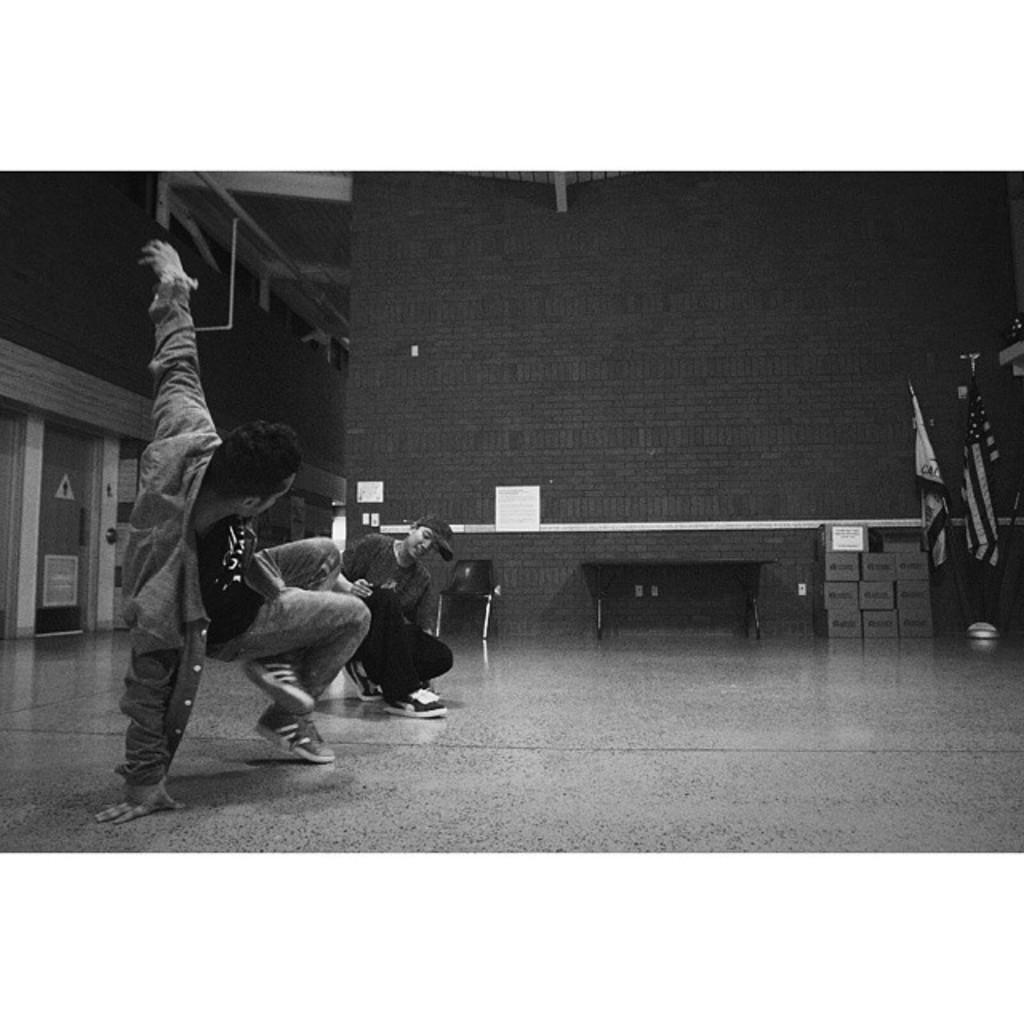What are the two men in the image doing? The two men are dancing in the image. Where are the men dancing? The men are dancing on the floor. What can be seen on the right side of the image? There are two flags on the right side of the image. What is visible in the background of the image? There is a wall in the background of the image. How is the image presented in terms of color? The image is black and white. What type of cloth is draped over the cart in the image? There is no cart or cloth present in the image. 